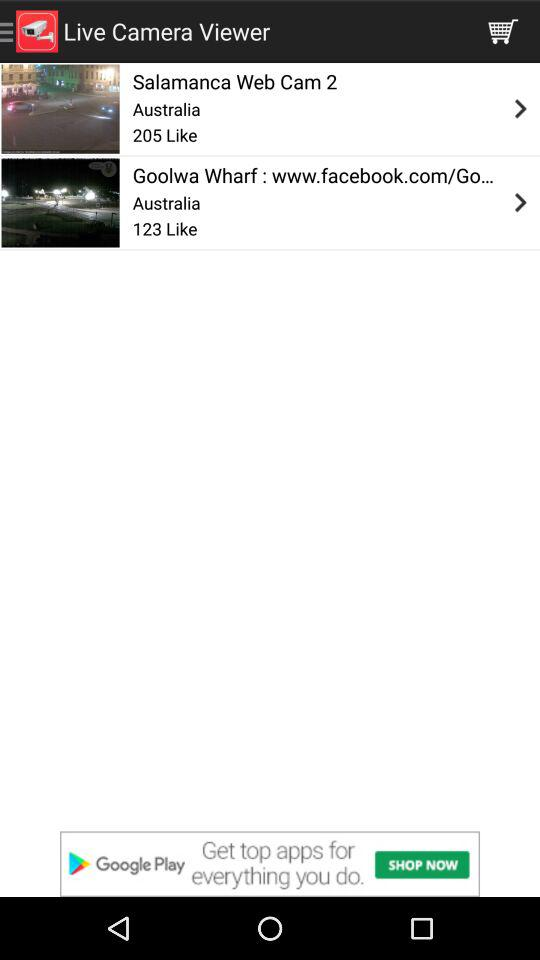How many likes do the items combined have?
Answer the question using a single word or phrase. 328 